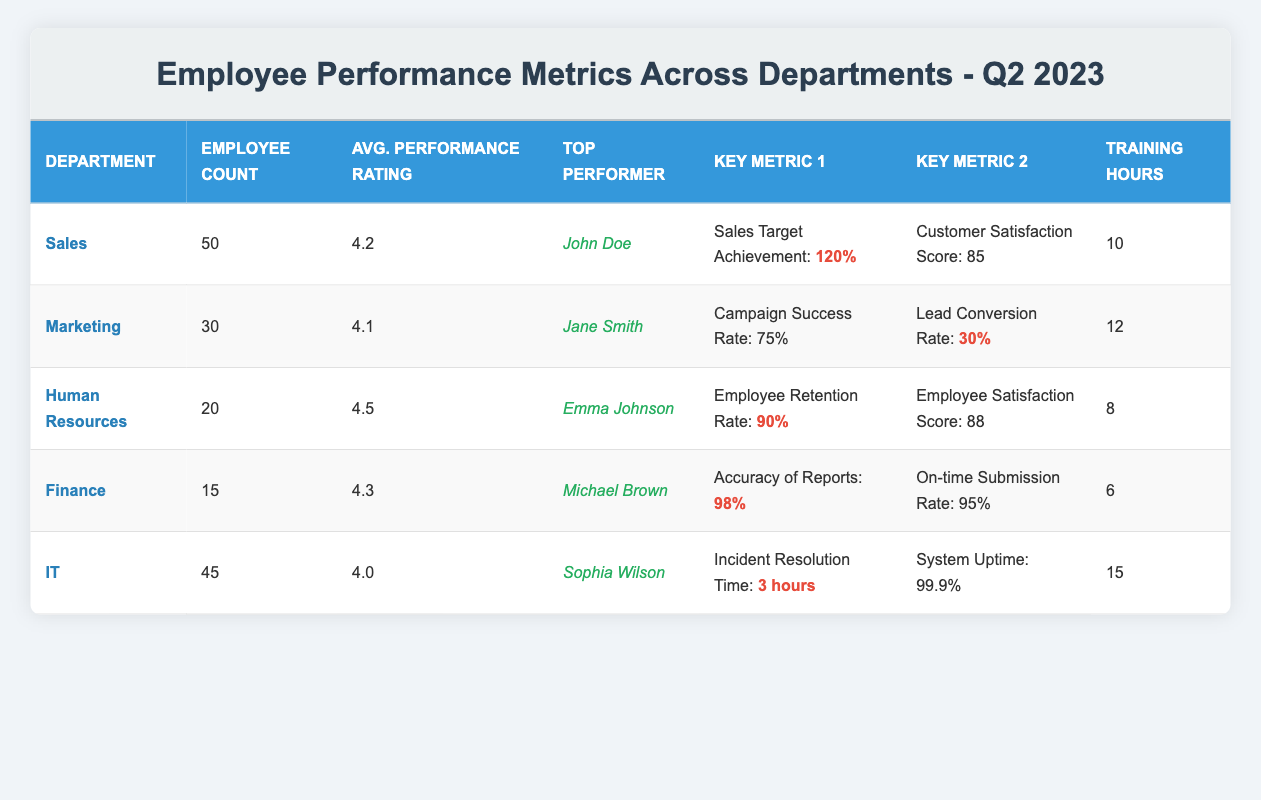What is the average performance rating for the Finance department? The table indicates the average performance rating for the Finance department is 4.3.
Answer: 4.3 Which department has the highest employee retention rate? The Human Resources department has an employee retention rate of 90%, which is the highest among all departments listed in the table.
Answer: Human Resources How many more training hours does the IT department provide compared to the Finance department? The IT department offers 15 training hours while the Finance department only provides 6 hours. The difference is 15 - 6 = 9 hours.
Answer: 9 Is Jane Smith the top performer in the Marketing department? Yes, the table shows that Jane Smith is listed as the top performer for the Marketing department.
Answer: Yes Which department has the highest average performance rating? The Human Resources department has the highest average performance rating of 4.5, surpassing other departments.
Answer: Human Resources What is the total employee count for the Sales and IT departments combined? The Sales department has 50 employees and the IT department has 45 employees. Their total employee count is 50 + 45 = 95.
Answer: 95 Does the Marketing department have a customer satisfaction score reported in the table? No, the table does not show a customer satisfaction score for the Marketing department.
Answer: No Which department achieved the highest percentage of its sales target? The Sales department achieved a sales target of 120%, which is the highest percentage achieved compared to the metrics of other departments.
Answer: Sales How many more employees are there in the Sales department than in Human Resources? The Sales department has 50 employees, while Human Resources has 20. The difference is 50 - 20 = 30 employees.
Answer: 30 